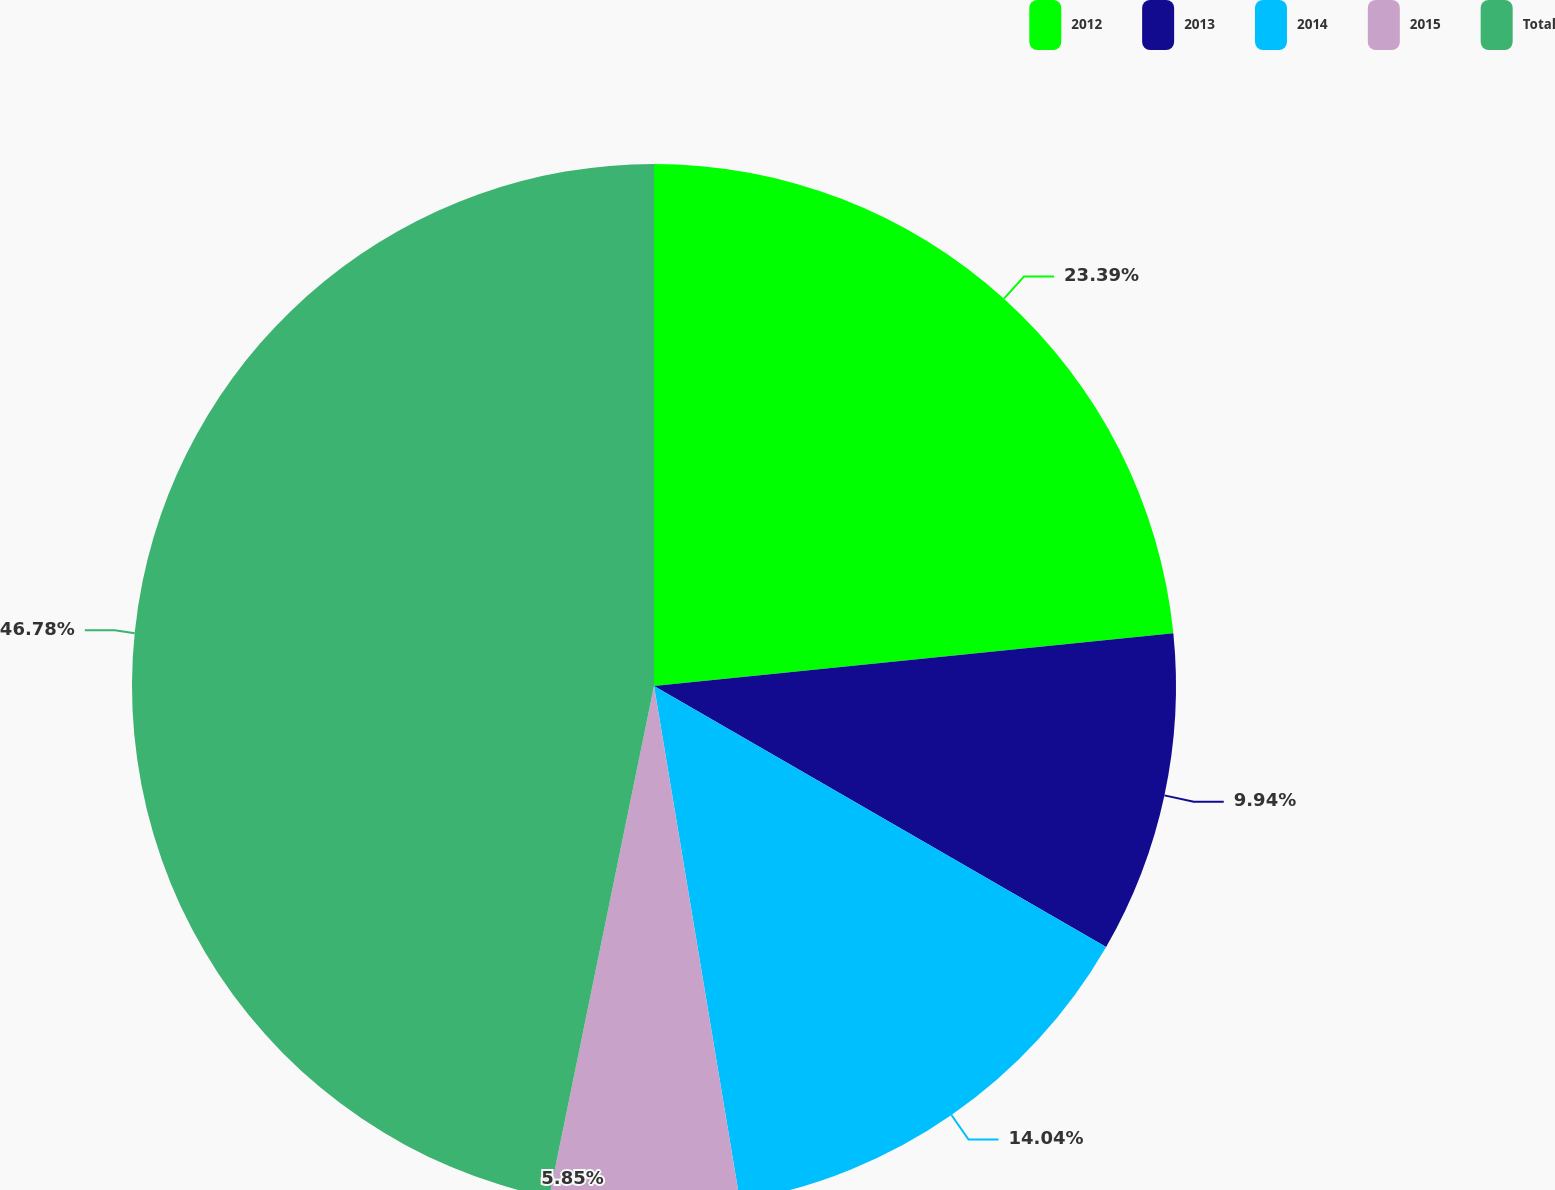Convert chart to OTSL. <chart><loc_0><loc_0><loc_500><loc_500><pie_chart><fcel>2012<fcel>2013<fcel>2014<fcel>2015<fcel>Total<nl><fcel>23.39%<fcel>9.94%<fcel>14.04%<fcel>5.85%<fcel>46.78%<nl></chart> 